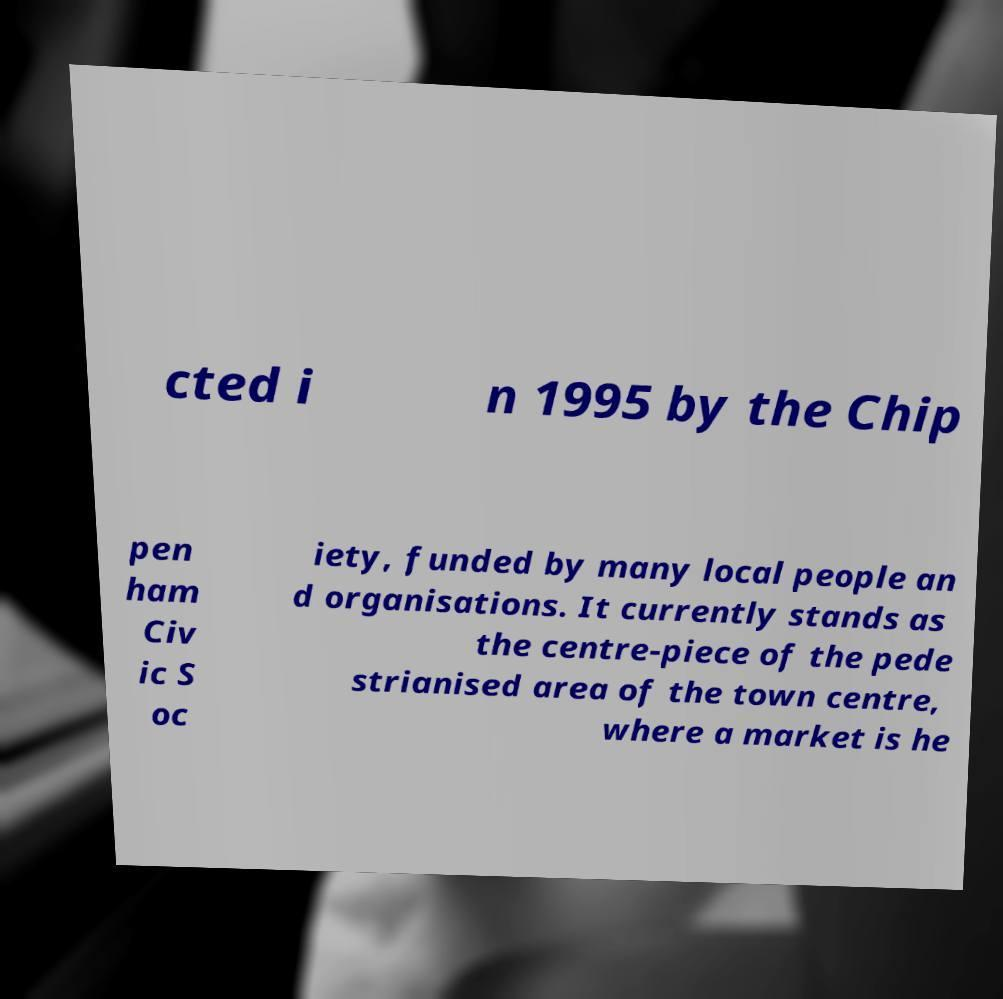Could you extract and type out the text from this image? cted i n 1995 by the Chip pen ham Civ ic S oc iety, funded by many local people an d organisations. It currently stands as the centre-piece of the pede strianised area of the town centre, where a market is he 